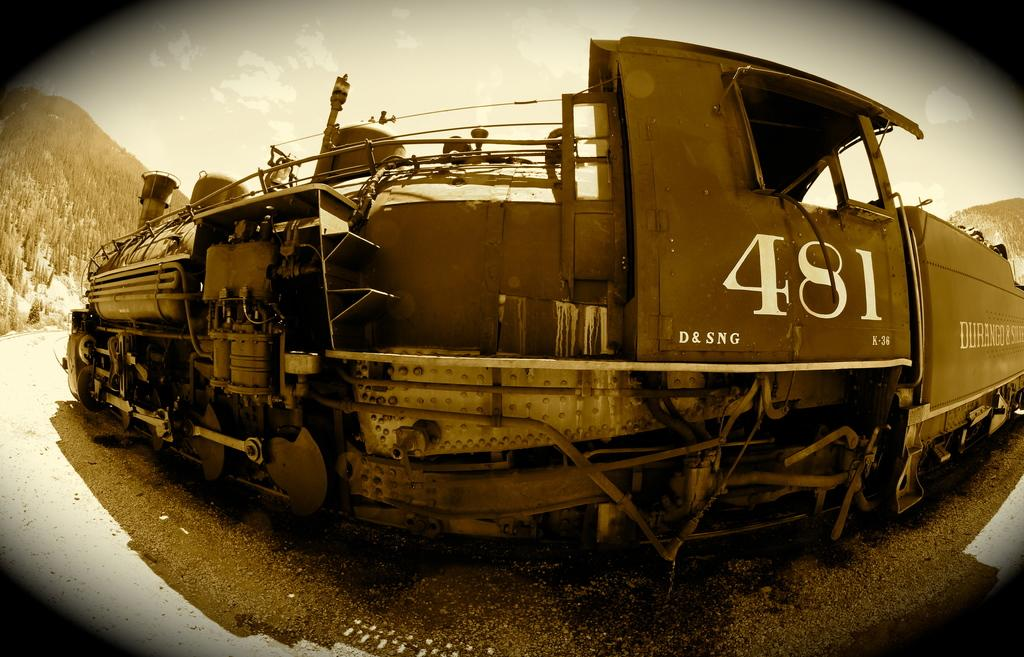<image>
Provide a brief description of the given image. The numbers 481 on the side of the train 